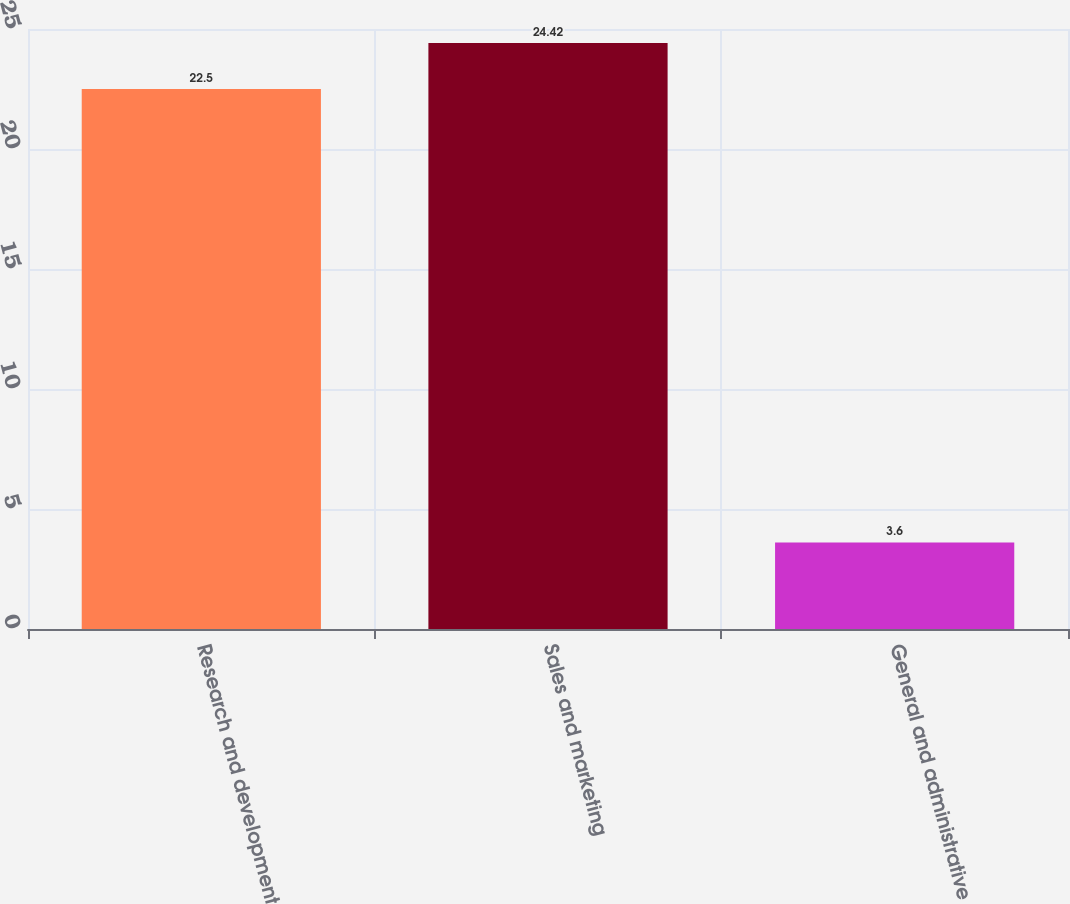<chart> <loc_0><loc_0><loc_500><loc_500><bar_chart><fcel>Research and development<fcel>Sales and marketing<fcel>General and administrative<nl><fcel>22.5<fcel>24.42<fcel>3.6<nl></chart> 